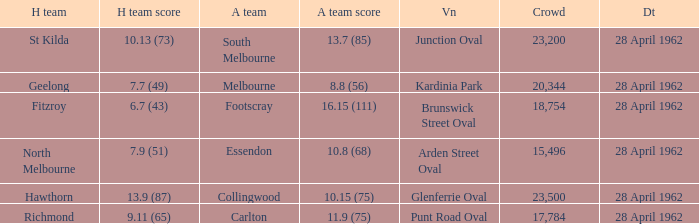What was the crowd size when there was a home team score of 10.13 (73)? 23200.0. 